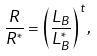<formula> <loc_0><loc_0><loc_500><loc_500>\frac { R } { R ^ { * } } = \left ( \frac { L _ { B } } { L _ { B } ^ { * } } \right ) ^ { t } ,</formula> 